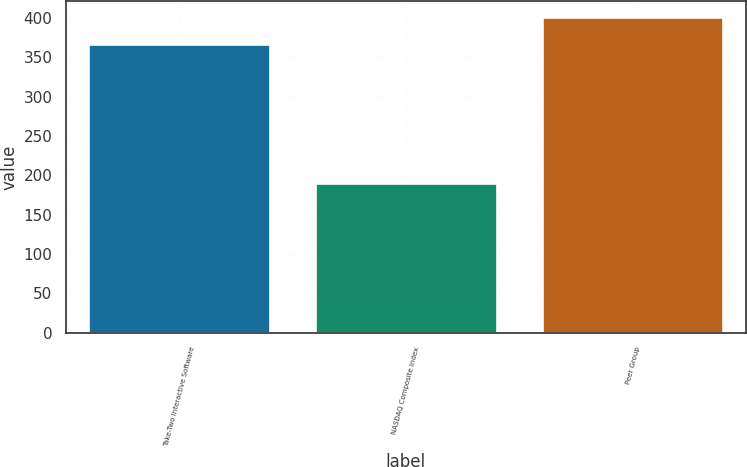Convert chart. <chart><loc_0><loc_0><loc_500><loc_500><bar_chart><fcel>Take-Two Interactive Software<fcel>NASDAQ Composite Index<fcel>Peer Group<nl><fcel>367<fcel>189.99<fcel>400.93<nl></chart> 